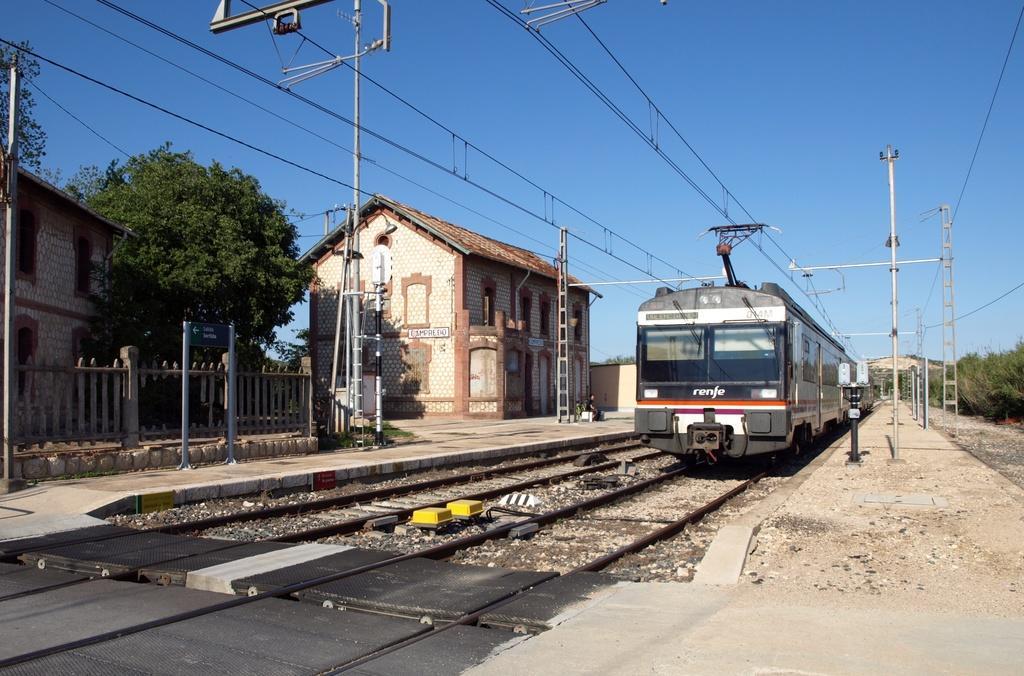Describe this image in one or two sentences. In this image there is a train on the railway track. Beside the train there is a platform on which there is a building. Beside the building there are electric poles to which there are wires. On the left side there is a fence beside the track. In the background there is a tree. At the top there is the sky. 